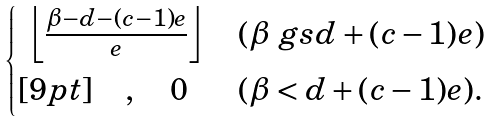<formula> <loc_0><loc_0><loc_500><loc_500>\begin{cases} \ \left \lfloor \frac { \beta - d - ( c - 1 ) e } e \right \rfloor & ( \beta \ g s d + ( c - 1 ) e ) \\ [ 9 p t ] \quad , \quad 0 & ( \beta < d + ( c - 1 ) e ) . \end{cases}</formula> 